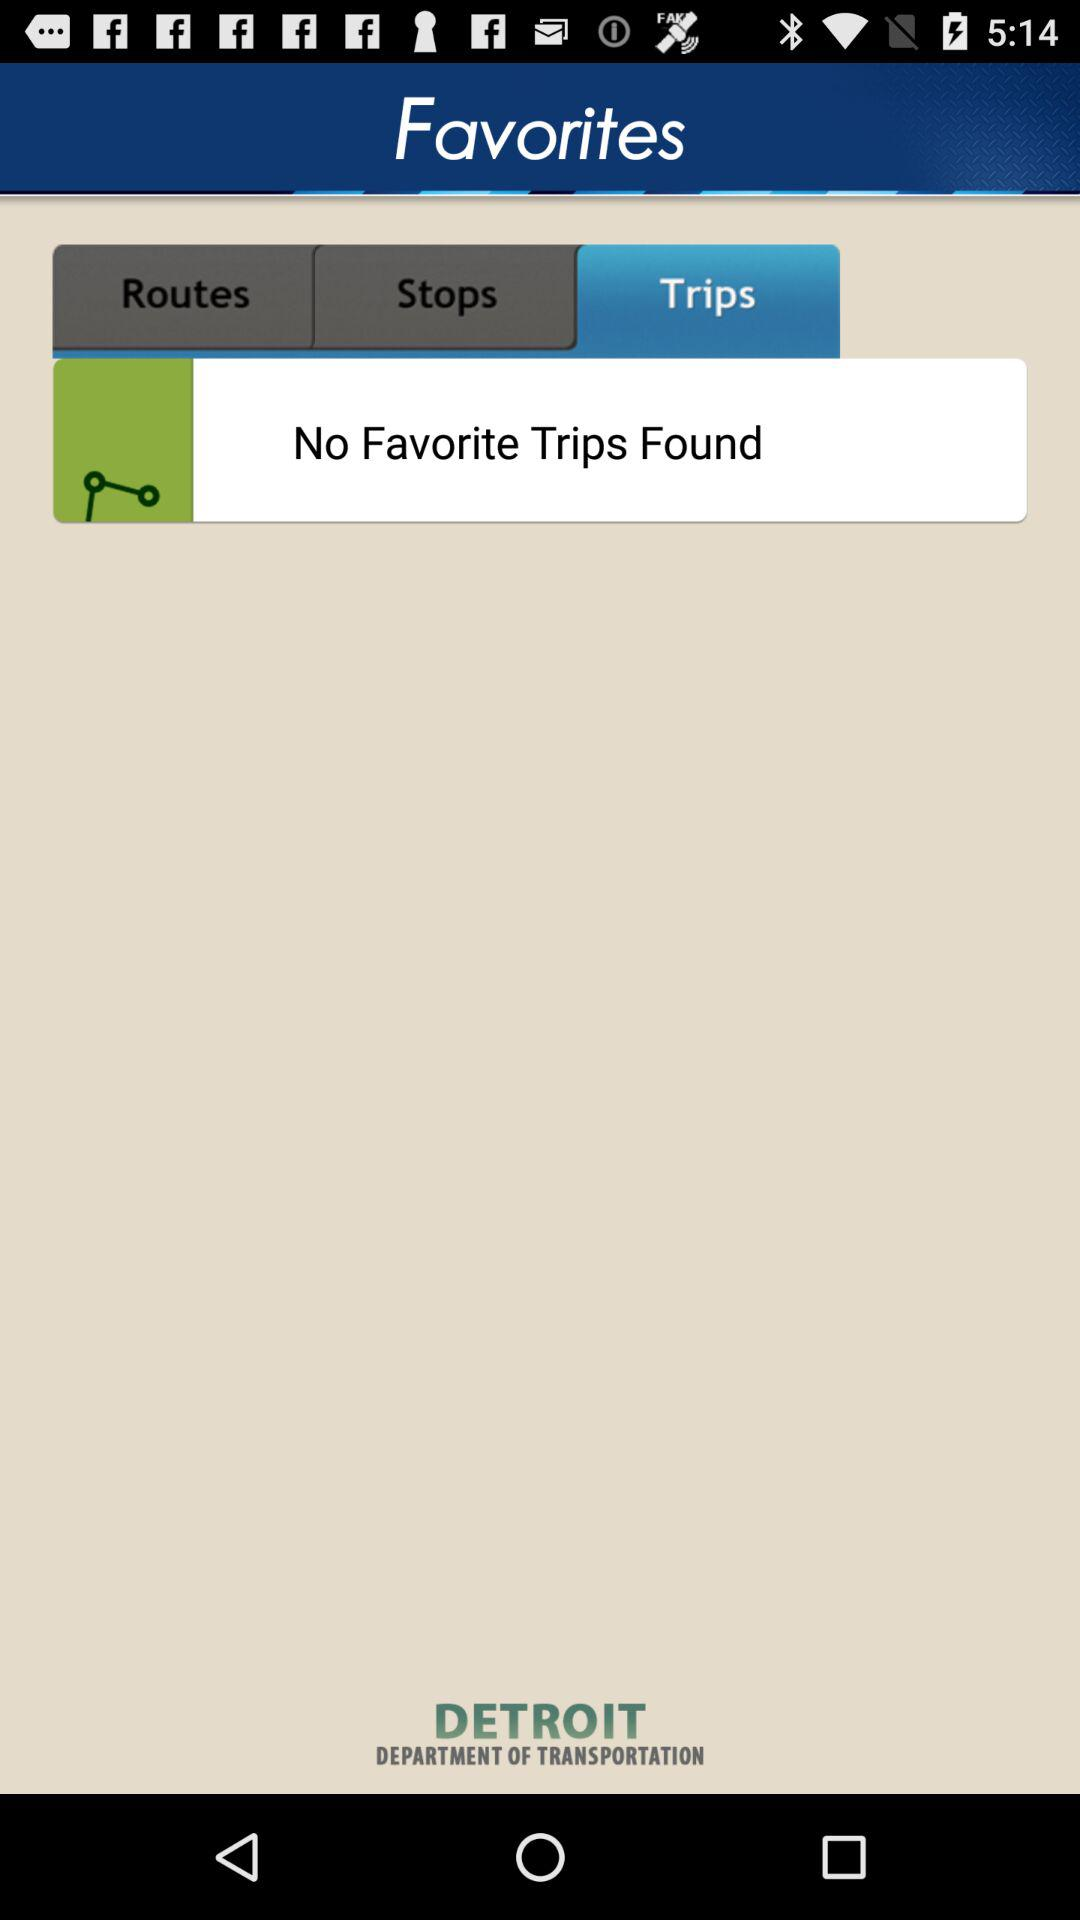How many favorite trips were found? There were no favorite trips found. 